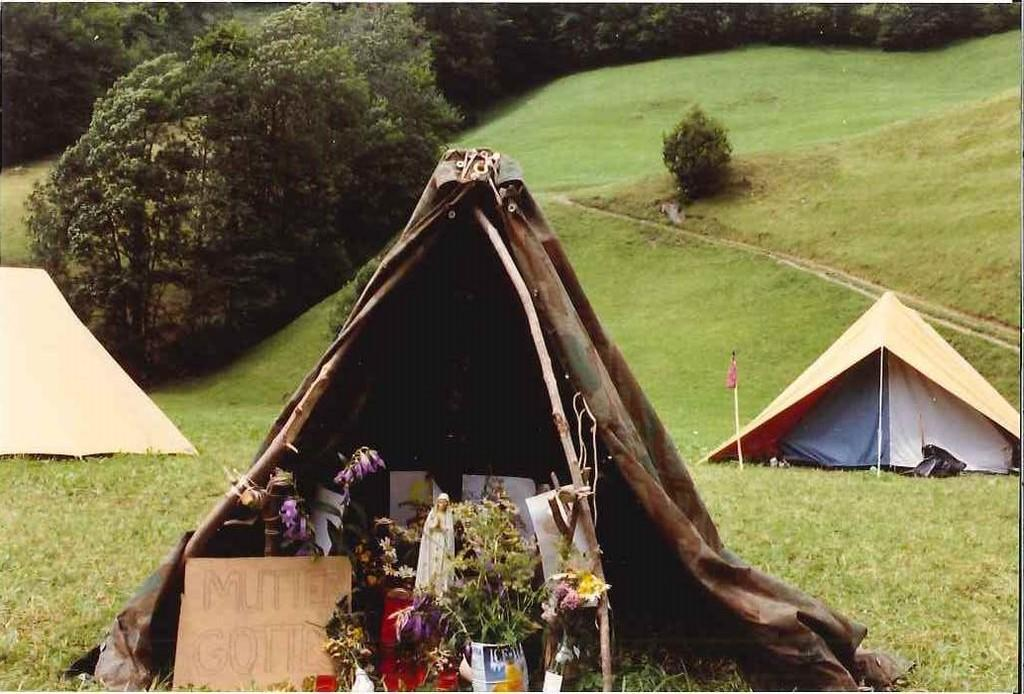What type of temporary shelters can be seen in the image? There are tents in the image. What decorative items are present in the image? There are flower vases in the image. What is the flat, rectangular object in the image? There is a board in the image. What type of ground surface is visible at the bottom of the image? There is grass at the bottom of the image. What type of vegetation can be seen in the distance in the image? There are trees in the background of the image. What type of honey is being served in the flower vases in the image? There is no honey present in the image; it features tents, flower vases, a board, grass, and trees. What type of collar is visible on the trees in the background of the image? There is no collar present in the image; it features tents, flower vases, a board, grass, and trees. 